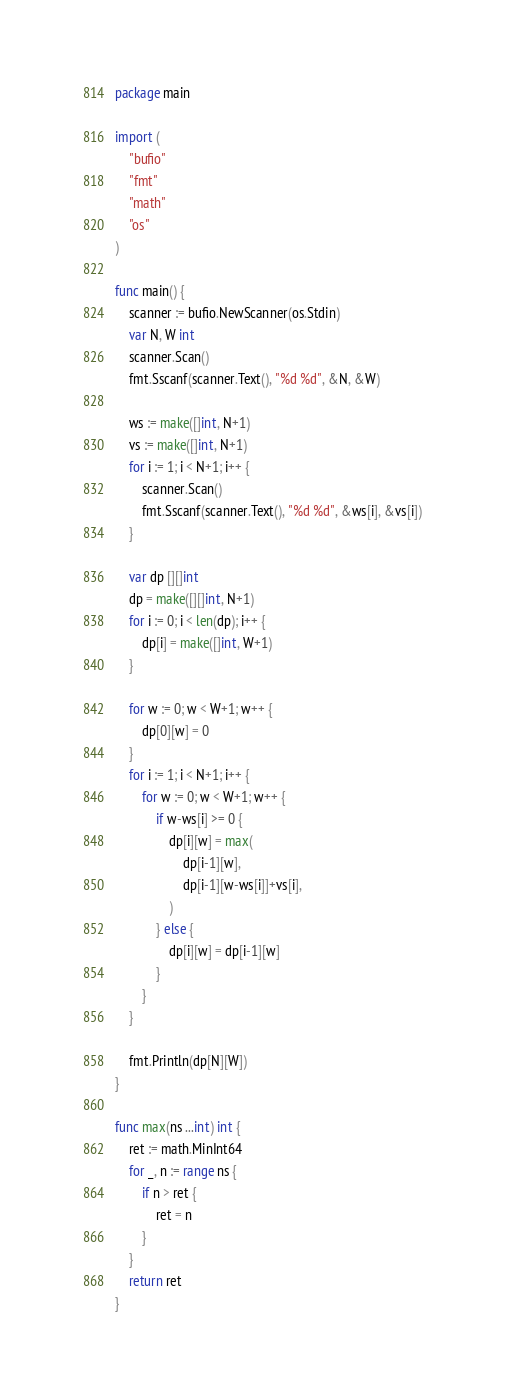Convert code to text. <code><loc_0><loc_0><loc_500><loc_500><_Go_>package main

import (
	"bufio"
	"fmt"
	"math"
	"os"
)

func main() {
	scanner := bufio.NewScanner(os.Stdin)
	var N, W int
	scanner.Scan()
	fmt.Sscanf(scanner.Text(), "%d %d", &N, &W)

	ws := make([]int, N+1)
	vs := make([]int, N+1)
	for i := 1; i < N+1; i++ {
		scanner.Scan()
		fmt.Sscanf(scanner.Text(), "%d %d", &ws[i], &vs[i])
	}

	var dp [][]int
	dp = make([][]int, N+1)
	for i := 0; i < len(dp); i++ {
		dp[i] = make([]int, W+1)
	}

	for w := 0; w < W+1; w++ {
		dp[0][w] = 0
	}
	for i := 1; i < N+1; i++ {
		for w := 0; w < W+1; w++ {
			if w-ws[i] >= 0 {
				dp[i][w] = max(
					dp[i-1][w],
					dp[i-1][w-ws[i]]+vs[i],
				)
			} else {
				dp[i][w] = dp[i-1][w]
			}
		}
	}

	fmt.Println(dp[N][W])
}

func max(ns ...int) int {
	ret := math.MinInt64
	for _, n := range ns {
		if n > ret {
			ret = n
		}
	}
	return ret
}
</code> 